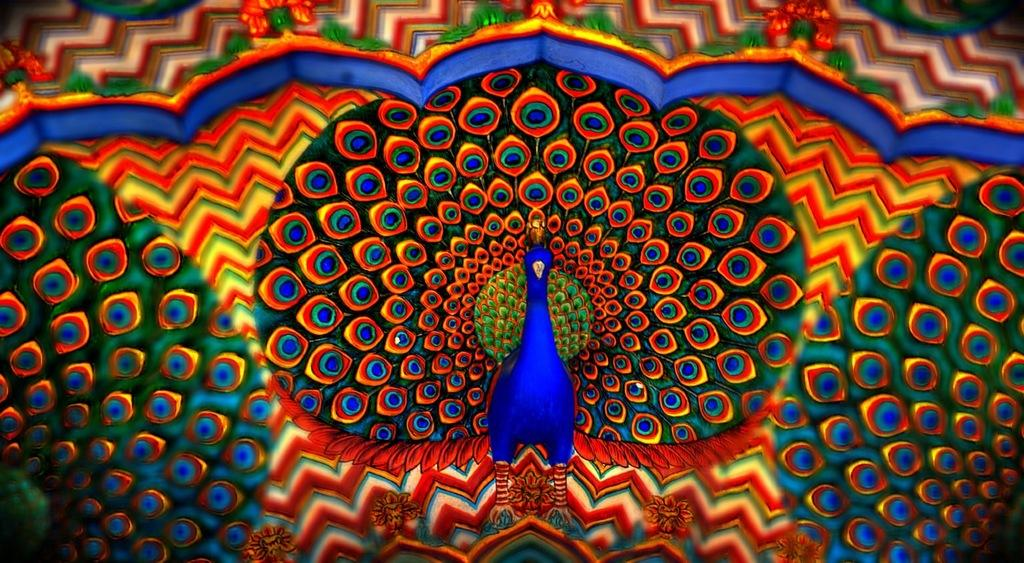What type of picture is shown in the image? The picture is animated. What animals can be seen in the animated picture? There are peacocks in the picture. Where is the park located in the image? There is no park present in the image; it features animated peacocks. What type of bird is the chicken in the image? There is no chicken present in the image; it features animated peacocks. 